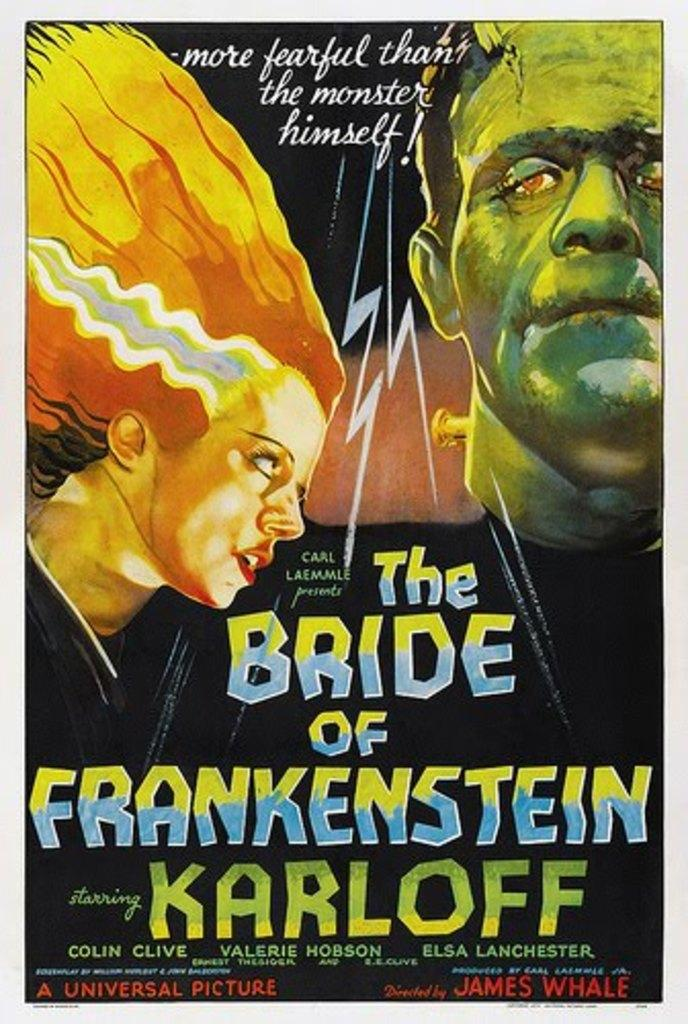<image>
Write a terse but informative summary of the picture. A cover is titled The Bride of Frankenstein and has pictures of Frankenstein and a woman on it. 